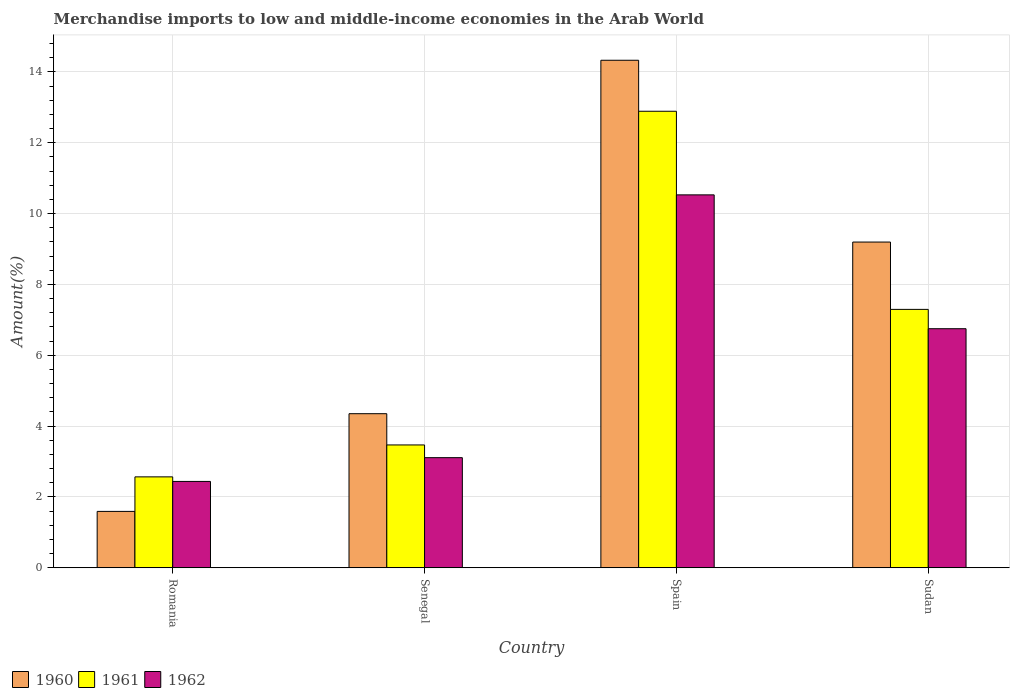How many different coloured bars are there?
Offer a very short reply. 3. Are the number of bars on each tick of the X-axis equal?
Your response must be concise. Yes. How many bars are there on the 4th tick from the left?
Provide a succinct answer. 3. What is the percentage of amount earned from merchandise imports in 1962 in Romania?
Offer a terse response. 2.44. Across all countries, what is the maximum percentage of amount earned from merchandise imports in 1962?
Provide a succinct answer. 10.53. Across all countries, what is the minimum percentage of amount earned from merchandise imports in 1962?
Provide a succinct answer. 2.44. In which country was the percentage of amount earned from merchandise imports in 1962 minimum?
Your answer should be very brief. Romania. What is the total percentage of amount earned from merchandise imports in 1961 in the graph?
Offer a very short reply. 26.22. What is the difference between the percentage of amount earned from merchandise imports in 1961 in Romania and that in Senegal?
Your answer should be compact. -0.9. What is the difference between the percentage of amount earned from merchandise imports in 1962 in Sudan and the percentage of amount earned from merchandise imports in 1961 in Senegal?
Keep it short and to the point. 3.28. What is the average percentage of amount earned from merchandise imports in 1962 per country?
Provide a succinct answer. 5.71. What is the difference between the percentage of amount earned from merchandise imports of/in 1962 and percentage of amount earned from merchandise imports of/in 1961 in Senegal?
Provide a succinct answer. -0.36. What is the ratio of the percentage of amount earned from merchandise imports in 1960 in Spain to that in Sudan?
Provide a short and direct response. 1.56. What is the difference between the highest and the second highest percentage of amount earned from merchandise imports in 1961?
Your answer should be compact. -9.42. What is the difference between the highest and the lowest percentage of amount earned from merchandise imports in 1960?
Give a very brief answer. 12.74. In how many countries, is the percentage of amount earned from merchandise imports in 1962 greater than the average percentage of amount earned from merchandise imports in 1962 taken over all countries?
Your answer should be very brief. 2. What does the 3rd bar from the right in Spain represents?
Make the answer very short. 1960. How many bars are there?
Offer a very short reply. 12. How many countries are there in the graph?
Provide a short and direct response. 4. Does the graph contain any zero values?
Make the answer very short. No. Where does the legend appear in the graph?
Provide a short and direct response. Bottom left. How many legend labels are there?
Make the answer very short. 3. How are the legend labels stacked?
Make the answer very short. Horizontal. What is the title of the graph?
Keep it short and to the point. Merchandise imports to low and middle-income economies in the Arab World. Does "1998" appear as one of the legend labels in the graph?
Offer a very short reply. No. What is the label or title of the X-axis?
Give a very brief answer. Country. What is the label or title of the Y-axis?
Offer a very short reply. Amount(%). What is the Amount(%) in 1960 in Romania?
Your response must be concise. 1.59. What is the Amount(%) in 1961 in Romania?
Keep it short and to the point. 2.57. What is the Amount(%) of 1962 in Romania?
Your answer should be compact. 2.44. What is the Amount(%) in 1960 in Senegal?
Your answer should be compact. 4.35. What is the Amount(%) of 1961 in Senegal?
Your answer should be very brief. 3.47. What is the Amount(%) of 1962 in Senegal?
Offer a terse response. 3.11. What is the Amount(%) of 1960 in Spain?
Ensure brevity in your answer.  14.33. What is the Amount(%) in 1961 in Spain?
Your answer should be compact. 12.89. What is the Amount(%) of 1962 in Spain?
Your response must be concise. 10.53. What is the Amount(%) of 1960 in Sudan?
Provide a succinct answer. 9.2. What is the Amount(%) of 1961 in Sudan?
Provide a short and direct response. 7.3. What is the Amount(%) in 1962 in Sudan?
Provide a short and direct response. 6.75. Across all countries, what is the maximum Amount(%) of 1960?
Your response must be concise. 14.33. Across all countries, what is the maximum Amount(%) in 1961?
Provide a succinct answer. 12.89. Across all countries, what is the maximum Amount(%) in 1962?
Your response must be concise. 10.53. Across all countries, what is the minimum Amount(%) of 1960?
Provide a short and direct response. 1.59. Across all countries, what is the minimum Amount(%) of 1961?
Provide a succinct answer. 2.57. Across all countries, what is the minimum Amount(%) in 1962?
Give a very brief answer. 2.44. What is the total Amount(%) in 1960 in the graph?
Provide a succinct answer. 29.47. What is the total Amount(%) in 1961 in the graph?
Offer a terse response. 26.22. What is the total Amount(%) in 1962 in the graph?
Keep it short and to the point. 22.83. What is the difference between the Amount(%) of 1960 in Romania and that in Senegal?
Provide a short and direct response. -2.76. What is the difference between the Amount(%) of 1961 in Romania and that in Senegal?
Ensure brevity in your answer.  -0.9. What is the difference between the Amount(%) of 1962 in Romania and that in Senegal?
Make the answer very short. -0.67. What is the difference between the Amount(%) in 1960 in Romania and that in Spain?
Ensure brevity in your answer.  -12.74. What is the difference between the Amount(%) in 1961 in Romania and that in Spain?
Your answer should be very brief. -10.32. What is the difference between the Amount(%) in 1962 in Romania and that in Spain?
Your response must be concise. -8.09. What is the difference between the Amount(%) of 1960 in Romania and that in Sudan?
Your answer should be compact. -7.61. What is the difference between the Amount(%) of 1961 in Romania and that in Sudan?
Give a very brief answer. -4.73. What is the difference between the Amount(%) in 1962 in Romania and that in Sudan?
Your answer should be very brief. -4.31. What is the difference between the Amount(%) of 1960 in Senegal and that in Spain?
Offer a very short reply. -9.98. What is the difference between the Amount(%) in 1961 in Senegal and that in Spain?
Offer a terse response. -9.42. What is the difference between the Amount(%) in 1962 in Senegal and that in Spain?
Keep it short and to the point. -7.42. What is the difference between the Amount(%) in 1960 in Senegal and that in Sudan?
Your response must be concise. -4.85. What is the difference between the Amount(%) in 1961 in Senegal and that in Sudan?
Provide a succinct answer. -3.83. What is the difference between the Amount(%) of 1962 in Senegal and that in Sudan?
Your response must be concise. -3.64. What is the difference between the Amount(%) of 1960 in Spain and that in Sudan?
Provide a short and direct response. 5.13. What is the difference between the Amount(%) in 1961 in Spain and that in Sudan?
Make the answer very short. 5.59. What is the difference between the Amount(%) in 1962 in Spain and that in Sudan?
Your response must be concise. 3.78. What is the difference between the Amount(%) in 1960 in Romania and the Amount(%) in 1961 in Senegal?
Give a very brief answer. -1.88. What is the difference between the Amount(%) of 1960 in Romania and the Amount(%) of 1962 in Senegal?
Your answer should be very brief. -1.52. What is the difference between the Amount(%) of 1961 in Romania and the Amount(%) of 1962 in Senegal?
Ensure brevity in your answer.  -0.54. What is the difference between the Amount(%) of 1960 in Romania and the Amount(%) of 1961 in Spain?
Keep it short and to the point. -11.3. What is the difference between the Amount(%) of 1960 in Romania and the Amount(%) of 1962 in Spain?
Make the answer very short. -8.94. What is the difference between the Amount(%) of 1961 in Romania and the Amount(%) of 1962 in Spain?
Offer a terse response. -7.96. What is the difference between the Amount(%) of 1960 in Romania and the Amount(%) of 1961 in Sudan?
Provide a short and direct response. -5.7. What is the difference between the Amount(%) in 1960 in Romania and the Amount(%) in 1962 in Sudan?
Your answer should be very brief. -5.16. What is the difference between the Amount(%) in 1961 in Romania and the Amount(%) in 1962 in Sudan?
Make the answer very short. -4.18. What is the difference between the Amount(%) in 1960 in Senegal and the Amount(%) in 1961 in Spain?
Your answer should be compact. -8.54. What is the difference between the Amount(%) in 1960 in Senegal and the Amount(%) in 1962 in Spain?
Your response must be concise. -6.18. What is the difference between the Amount(%) of 1961 in Senegal and the Amount(%) of 1962 in Spain?
Your answer should be very brief. -7.06. What is the difference between the Amount(%) of 1960 in Senegal and the Amount(%) of 1961 in Sudan?
Your answer should be very brief. -2.95. What is the difference between the Amount(%) in 1960 in Senegal and the Amount(%) in 1962 in Sudan?
Offer a terse response. -2.4. What is the difference between the Amount(%) in 1961 in Senegal and the Amount(%) in 1962 in Sudan?
Give a very brief answer. -3.28. What is the difference between the Amount(%) in 1960 in Spain and the Amount(%) in 1961 in Sudan?
Your response must be concise. 7.03. What is the difference between the Amount(%) of 1960 in Spain and the Amount(%) of 1962 in Sudan?
Your answer should be compact. 7.58. What is the difference between the Amount(%) of 1961 in Spain and the Amount(%) of 1962 in Sudan?
Provide a short and direct response. 6.14. What is the average Amount(%) in 1960 per country?
Offer a terse response. 7.37. What is the average Amount(%) in 1961 per country?
Keep it short and to the point. 6.55. What is the average Amount(%) of 1962 per country?
Your answer should be very brief. 5.71. What is the difference between the Amount(%) in 1960 and Amount(%) in 1961 in Romania?
Offer a terse response. -0.97. What is the difference between the Amount(%) of 1960 and Amount(%) of 1962 in Romania?
Keep it short and to the point. -0.85. What is the difference between the Amount(%) of 1961 and Amount(%) of 1962 in Romania?
Your answer should be compact. 0.13. What is the difference between the Amount(%) of 1960 and Amount(%) of 1961 in Senegal?
Provide a succinct answer. 0.88. What is the difference between the Amount(%) in 1960 and Amount(%) in 1962 in Senegal?
Your response must be concise. 1.24. What is the difference between the Amount(%) of 1961 and Amount(%) of 1962 in Senegal?
Provide a short and direct response. 0.36. What is the difference between the Amount(%) of 1960 and Amount(%) of 1961 in Spain?
Provide a short and direct response. 1.44. What is the difference between the Amount(%) of 1960 and Amount(%) of 1962 in Spain?
Provide a short and direct response. 3.8. What is the difference between the Amount(%) of 1961 and Amount(%) of 1962 in Spain?
Offer a very short reply. 2.36. What is the difference between the Amount(%) of 1960 and Amount(%) of 1961 in Sudan?
Your response must be concise. 1.9. What is the difference between the Amount(%) of 1960 and Amount(%) of 1962 in Sudan?
Your answer should be very brief. 2.45. What is the difference between the Amount(%) of 1961 and Amount(%) of 1962 in Sudan?
Offer a terse response. 0.55. What is the ratio of the Amount(%) of 1960 in Romania to that in Senegal?
Give a very brief answer. 0.37. What is the ratio of the Amount(%) in 1961 in Romania to that in Senegal?
Offer a very short reply. 0.74. What is the ratio of the Amount(%) in 1962 in Romania to that in Senegal?
Your answer should be compact. 0.78. What is the ratio of the Amount(%) of 1960 in Romania to that in Spain?
Offer a terse response. 0.11. What is the ratio of the Amount(%) in 1961 in Romania to that in Spain?
Make the answer very short. 0.2. What is the ratio of the Amount(%) in 1962 in Romania to that in Spain?
Ensure brevity in your answer.  0.23. What is the ratio of the Amount(%) of 1960 in Romania to that in Sudan?
Your answer should be compact. 0.17. What is the ratio of the Amount(%) of 1961 in Romania to that in Sudan?
Provide a short and direct response. 0.35. What is the ratio of the Amount(%) of 1962 in Romania to that in Sudan?
Offer a terse response. 0.36. What is the ratio of the Amount(%) of 1960 in Senegal to that in Spain?
Provide a short and direct response. 0.3. What is the ratio of the Amount(%) of 1961 in Senegal to that in Spain?
Keep it short and to the point. 0.27. What is the ratio of the Amount(%) in 1962 in Senegal to that in Spain?
Provide a short and direct response. 0.3. What is the ratio of the Amount(%) of 1960 in Senegal to that in Sudan?
Offer a terse response. 0.47. What is the ratio of the Amount(%) of 1961 in Senegal to that in Sudan?
Offer a very short reply. 0.48. What is the ratio of the Amount(%) of 1962 in Senegal to that in Sudan?
Provide a succinct answer. 0.46. What is the ratio of the Amount(%) in 1960 in Spain to that in Sudan?
Give a very brief answer. 1.56. What is the ratio of the Amount(%) in 1961 in Spain to that in Sudan?
Ensure brevity in your answer.  1.77. What is the ratio of the Amount(%) of 1962 in Spain to that in Sudan?
Offer a terse response. 1.56. What is the difference between the highest and the second highest Amount(%) in 1960?
Offer a very short reply. 5.13. What is the difference between the highest and the second highest Amount(%) of 1961?
Your answer should be compact. 5.59. What is the difference between the highest and the second highest Amount(%) in 1962?
Give a very brief answer. 3.78. What is the difference between the highest and the lowest Amount(%) in 1960?
Your response must be concise. 12.74. What is the difference between the highest and the lowest Amount(%) of 1961?
Keep it short and to the point. 10.32. What is the difference between the highest and the lowest Amount(%) of 1962?
Give a very brief answer. 8.09. 